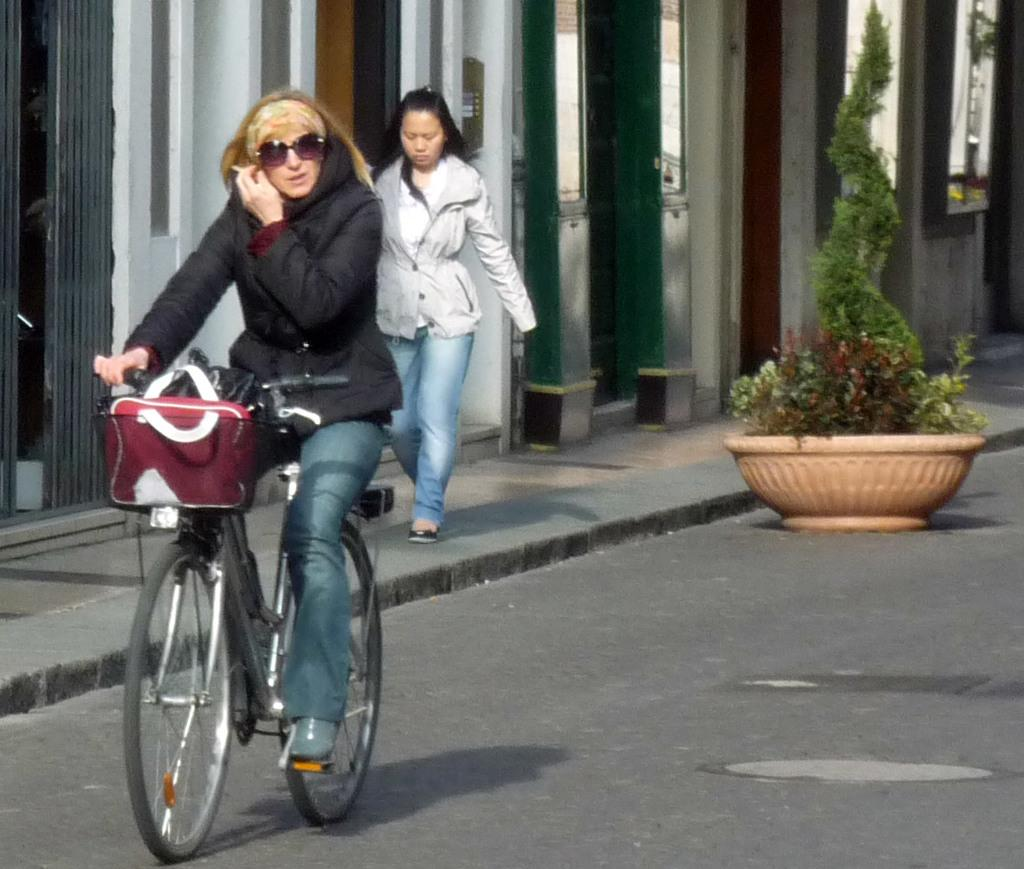What is the woman in the image doing? There is a woman riding a bicycle in the image. What is the other woman in the image doing? The other woman is walking in the image. What can be seen beside the woman walking? There is a building beside the woman walking. What is the big pot in the image used for? The big pot in the image is used for plants. What type of animal is the woman riding in the image? The woman is riding a bicycle, which is not an animal. 